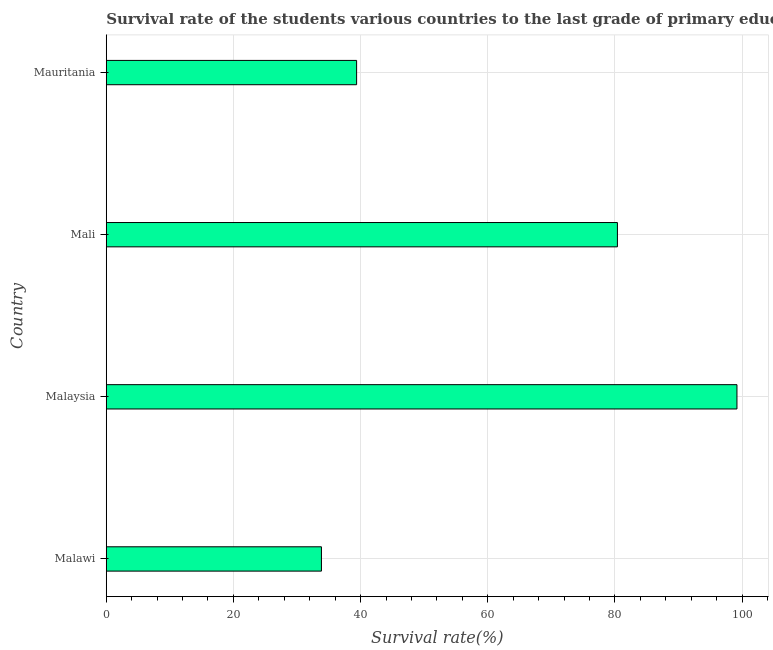Does the graph contain grids?
Offer a very short reply. Yes. What is the title of the graph?
Provide a succinct answer. Survival rate of the students various countries to the last grade of primary education. What is the label or title of the X-axis?
Your response must be concise. Survival rate(%). What is the label or title of the Y-axis?
Offer a terse response. Country. What is the survival rate in primary education in Mauritania?
Your answer should be compact. 39.37. Across all countries, what is the maximum survival rate in primary education?
Your answer should be compact. 99.19. Across all countries, what is the minimum survival rate in primary education?
Provide a succinct answer. 33.84. In which country was the survival rate in primary education maximum?
Offer a terse response. Malaysia. In which country was the survival rate in primary education minimum?
Offer a very short reply. Malawi. What is the sum of the survival rate in primary education?
Your response must be concise. 252.8. What is the difference between the survival rate in primary education in Malaysia and Mali?
Provide a short and direct response. 18.8. What is the average survival rate in primary education per country?
Keep it short and to the point. 63.2. What is the median survival rate in primary education?
Your answer should be very brief. 59.88. What is the ratio of the survival rate in primary education in Malawi to that in Mauritania?
Keep it short and to the point. 0.86. What is the difference between the highest and the second highest survival rate in primary education?
Your answer should be compact. 18.8. Is the sum of the survival rate in primary education in Malaysia and Mauritania greater than the maximum survival rate in primary education across all countries?
Offer a terse response. Yes. What is the difference between the highest and the lowest survival rate in primary education?
Provide a succinct answer. 65.35. In how many countries, is the survival rate in primary education greater than the average survival rate in primary education taken over all countries?
Your answer should be compact. 2. How many bars are there?
Make the answer very short. 4. What is the difference between two consecutive major ticks on the X-axis?
Provide a succinct answer. 20. What is the Survival rate(%) of Malawi?
Your response must be concise. 33.84. What is the Survival rate(%) of Malaysia?
Offer a very short reply. 99.19. What is the Survival rate(%) in Mali?
Make the answer very short. 80.39. What is the Survival rate(%) of Mauritania?
Make the answer very short. 39.37. What is the difference between the Survival rate(%) in Malawi and Malaysia?
Provide a short and direct response. -65.35. What is the difference between the Survival rate(%) in Malawi and Mali?
Keep it short and to the point. -46.55. What is the difference between the Survival rate(%) in Malawi and Mauritania?
Give a very brief answer. -5.53. What is the difference between the Survival rate(%) in Malaysia and Mali?
Offer a very short reply. 18.8. What is the difference between the Survival rate(%) in Malaysia and Mauritania?
Provide a short and direct response. 59.82. What is the difference between the Survival rate(%) in Mali and Mauritania?
Your answer should be very brief. 41.02. What is the ratio of the Survival rate(%) in Malawi to that in Malaysia?
Provide a succinct answer. 0.34. What is the ratio of the Survival rate(%) in Malawi to that in Mali?
Offer a very short reply. 0.42. What is the ratio of the Survival rate(%) in Malawi to that in Mauritania?
Keep it short and to the point. 0.86. What is the ratio of the Survival rate(%) in Malaysia to that in Mali?
Provide a short and direct response. 1.23. What is the ratio of the Survival rate(%) in Malaysia to that in Mauritania?
Offer a terse response. 2.52. What is the ratio of the Survival rate(%) in Mali to that in Mauritania?
Ensure brevity in your answer.  2.04. 